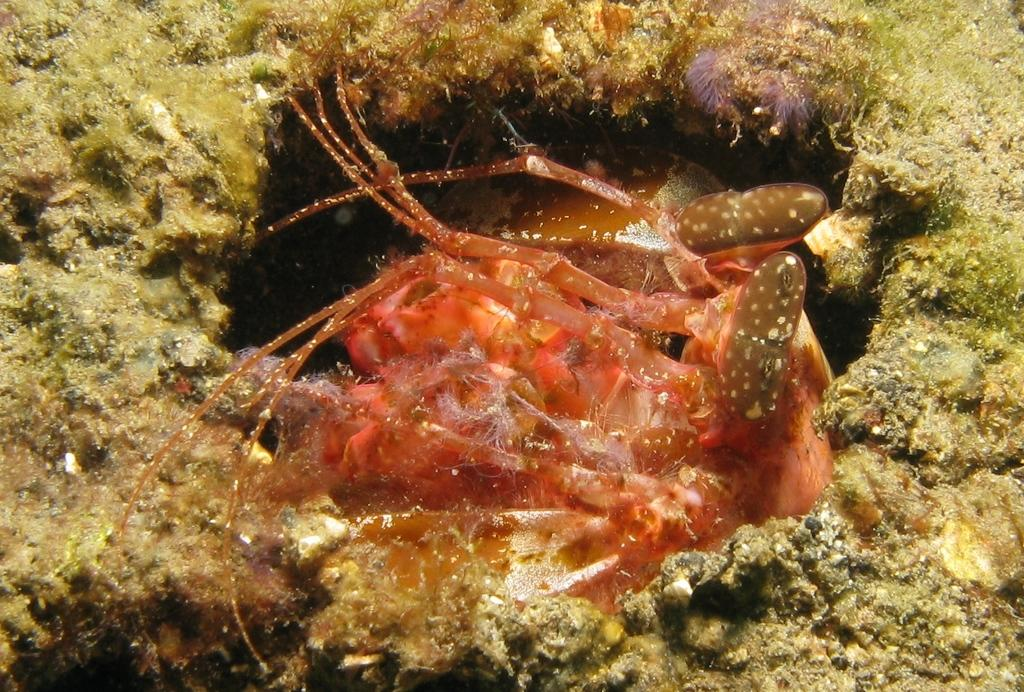What type of animal is depicted in the image? There is a sea creature in the image. What type of competition is taking place in the image? There is no competition present in the image; it features a sea creature. Can you tell me how many goldfish are swimming in the image? There is no goldfish present in the image; it features a sea creature. 